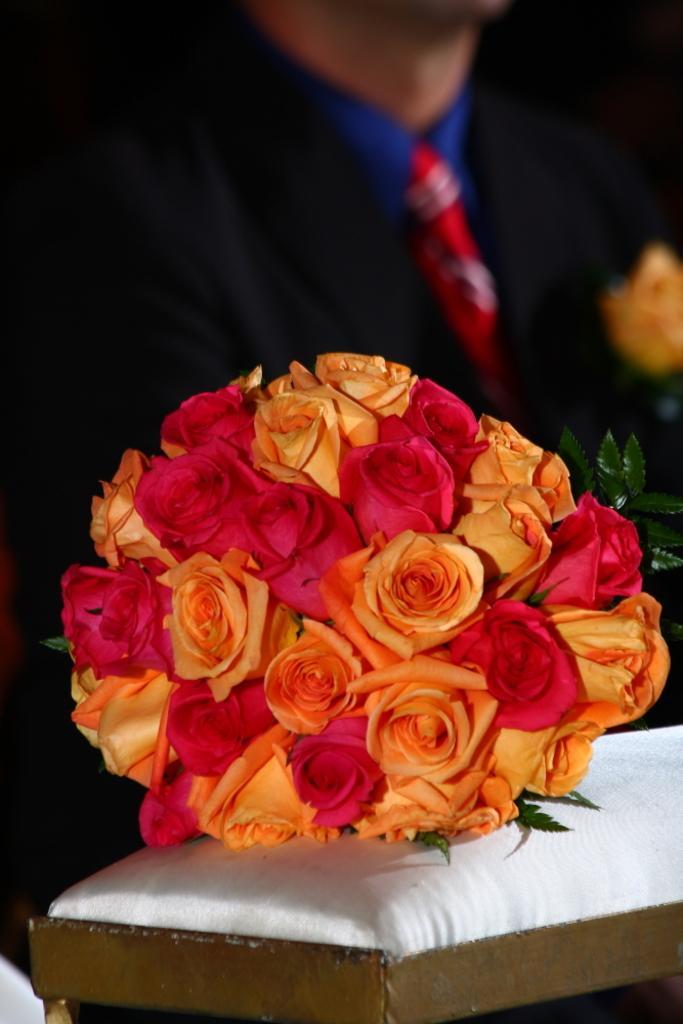In one or two sentences, can you explain what this image depicts? In the center of the image we can see a bouquet placed on the table. In the background there is a man. 